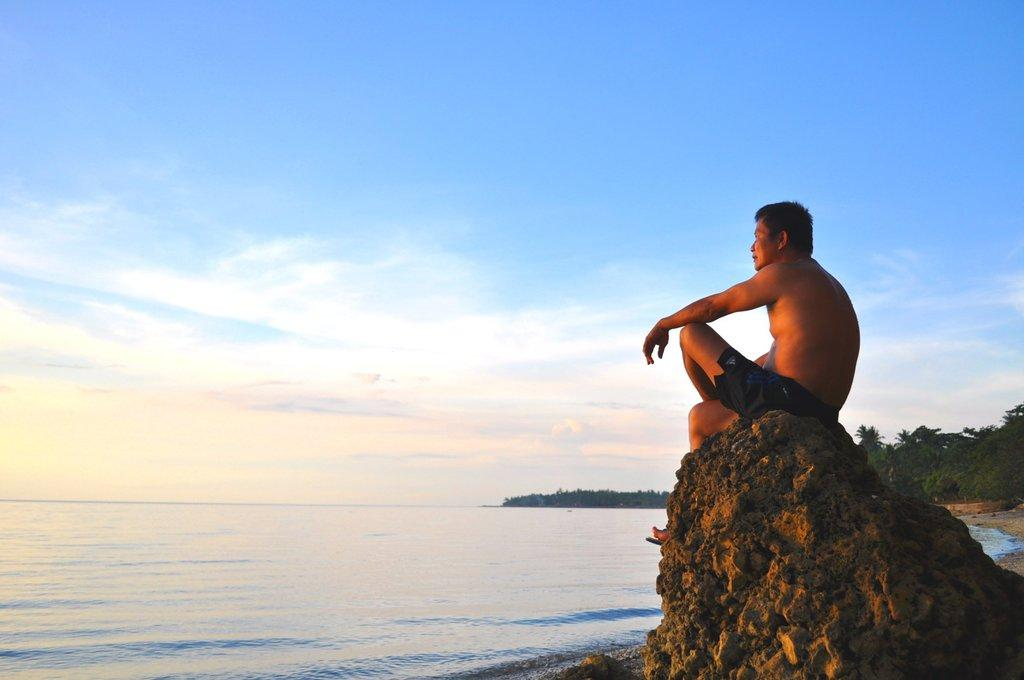What is the person in the image doing? The person is sitting on a rock in the image. What can be seen in the background of the image? There are trees, water, and other objects visible in the background of the image. What is visible at the top of the image? The sky is visible at the top of the image. What type of banana design can be seen on the person's shirt in the image? There is no banana design visible on the person's shirt in the image. What type of army is present in the image? There is no army present in the image; it features a person sitting on a rock with a background of trees, water, and other objects. 